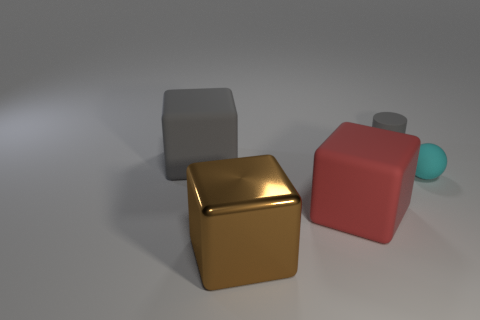Add 3 gray matte cylinders. How many objects exist? 8 Subtract all cylinders. How many objects are left? 4 Add 5 rubber spheres. How many rubber spheres are left? 6 Add 5 large purple shiny balls. How many large purple shiny balls exist? 5 Subtract 0 purple cubes. How many objects are left? 5 Subtract all large brown objects. Subtract all large gray cubes. How many objects are left? 3 